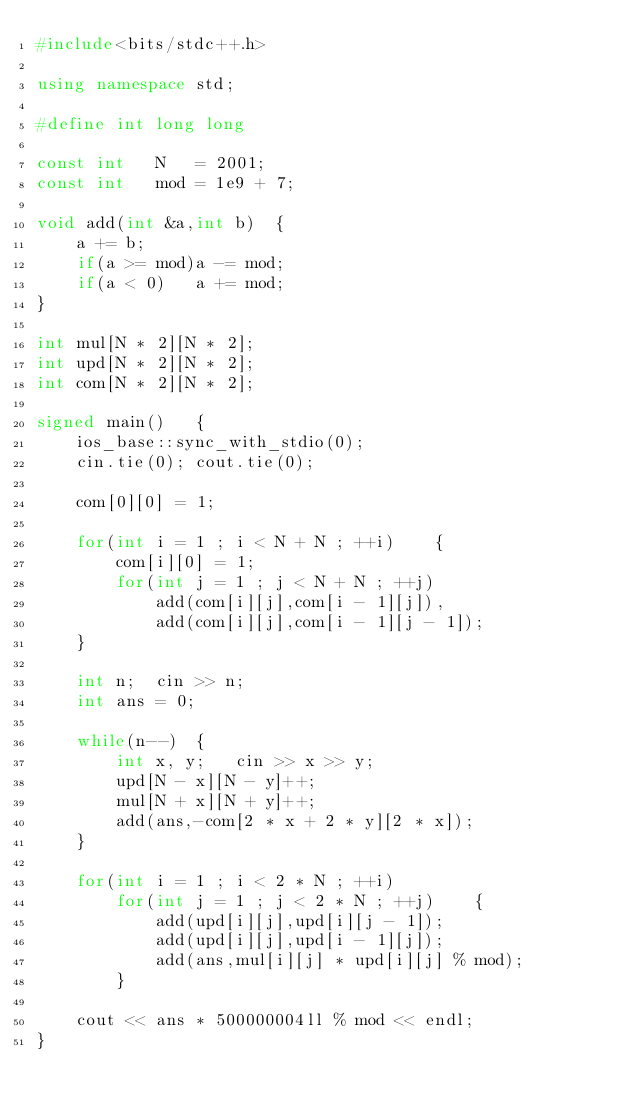Convert code to text. <code><loc_0><loc_0><loc_500><loc_500><_C++_>#include<bits/stdc++.h>

using namespace std;

#define int long long

const int   N   = 2001;
const int   mod = 1e9 + 7;

void add(int &a,int b)  {
    a += b;
    if(a >= mod)a -= mod;
    if(a < 0)   a += mod;
}

int mul[N * 2][N * 2];
int upd[N * 2][N * 2];
int com[N * 2][N * 2];

signed main()   {
    ios_base::sync_with_stdio(0);
    cin.tie(0); cout.tie(0);

    com[0][0] = 1;

    for(int i = 1 ; i < N + N ; ++i)    {
        com[i][0] = 1;
        for(int j = 1 ; j < N + N ; ++j)
            add(com[i][j],com[i - 1][j]),
            add(com[i][j],com[i - 1][j - 1]);
    }

    int n;  cin >> n;
    int ans = 0;

    while(n--)  {
        int x, y;   cin >> x >> y;
        upd[N - x][N - y]++;
        mul[N + x][N + y]++;
        add(ans,-com[2 * x + 2 * y][2 * x]);
    }

    for(int i = 1 ; i < 2 * N ; ++i)
        for(int j = 1 ; j < 2 * N ; ++j)    {
            add(upd[i][j],upd[i][j - 1]);
            add(upd[i][j],upd[i - 1][j]);
            add(ans,mul[i][j] * upd[i][j] % mod);
        }

    cout << ans * 500000004ll % mod << endl;
}
</code> 